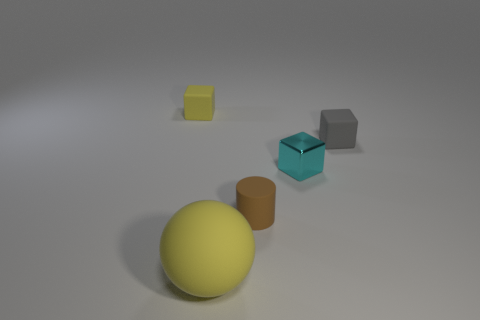Subtract all yellow blocks. How many blocks are left? 2 Subtract all yellow blocks. How many blocks are left? 2 Add 4 tiny brown objects. How many objects exist? 9 Subtract all cylinders. How many objects are left? 4 Add 5 tiny shiny cubes. How many tiny shiny cubes are left? 6 Add 2 tiny shiny objects. How many tiny shiny objects exist? 3 Subtract 0 purple cylinders. How many objects are left? 5 Subtract all brown balls. Subtract all green cylinders. How many balls are left? 1 Subtract all large things. Subtract all tiny gray matte objects. How many objects are left? 3 